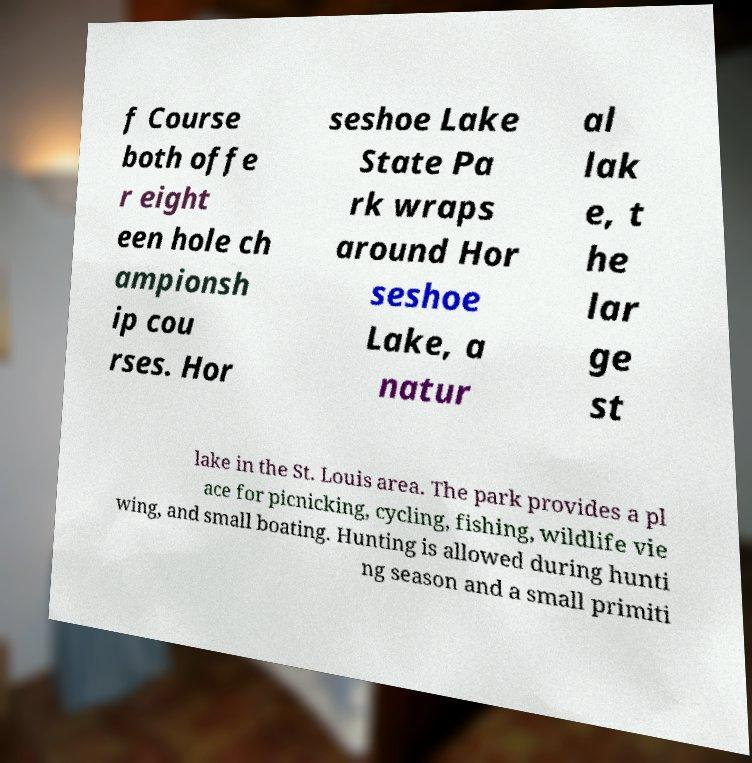Could you extract and type out the text from this image? f Course both offe r eight een hole ch ampionsh ip cou rses. Hor seshoe Lake State Pa rk wraps around Hor seshoe Lake, a natur al lak e, t he lar ge st lake in the St. Louis area. The park provides a pl ace for picnicking, cycling, fishing, wildlife vie wing, and small boating. Hunting is allowed during hunti ng season and a small primiti 